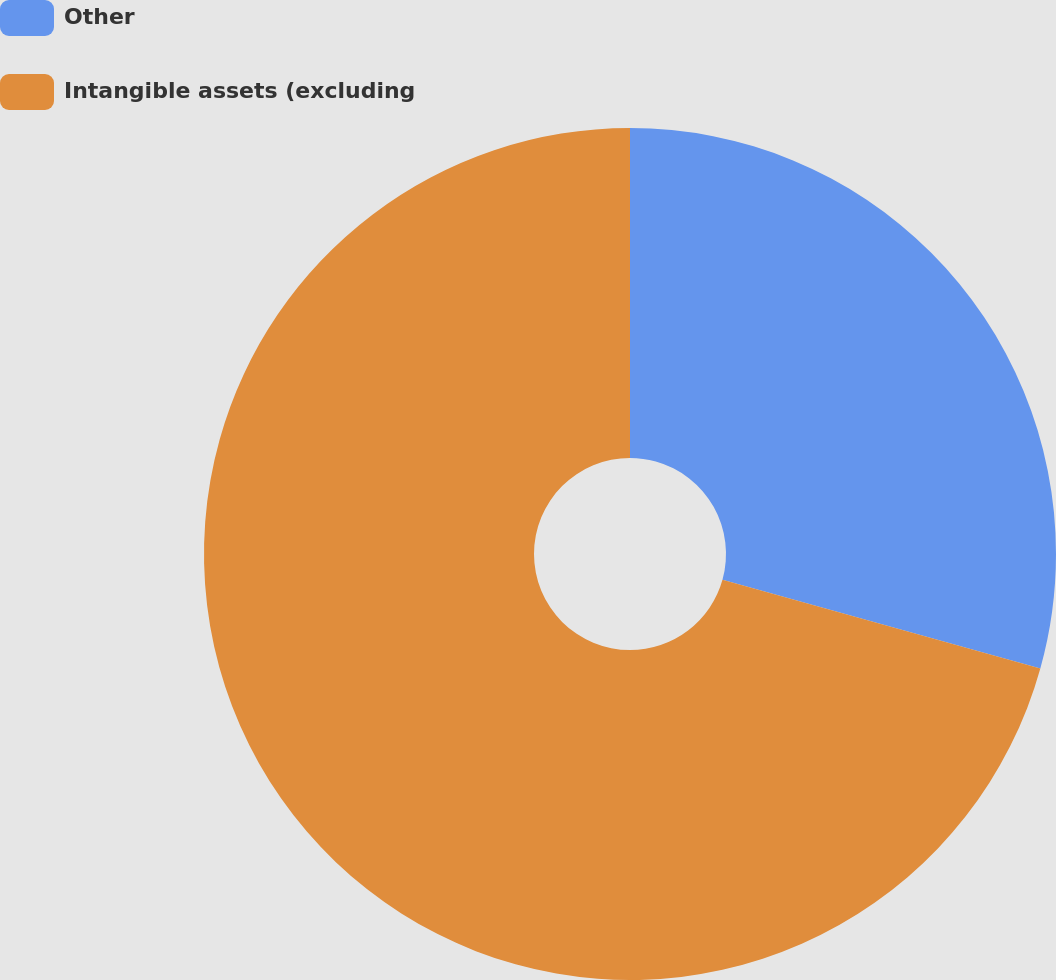Convert chart. <chart><loc_0><loc_0><loc_500><loc_500><pie_chart><fcel>Other<fcel>Intangible assets (excluding<nl><fcel>29.33%<fcel>70.67%<nl></chart> 